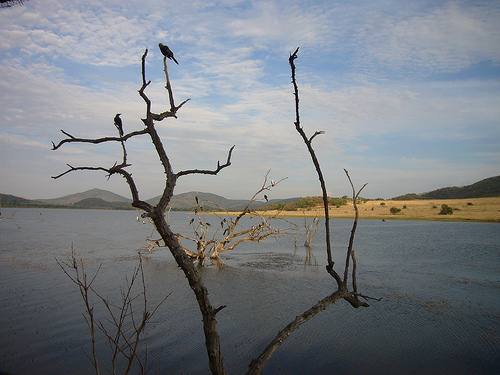<image>
Is the bird in the sky? No. The bird is not contained within the sky. These objects have a different spatial relationship. Is there a bird in the sky? No. The bird is not contained within the sky. These objects have a different spatial relationship. 